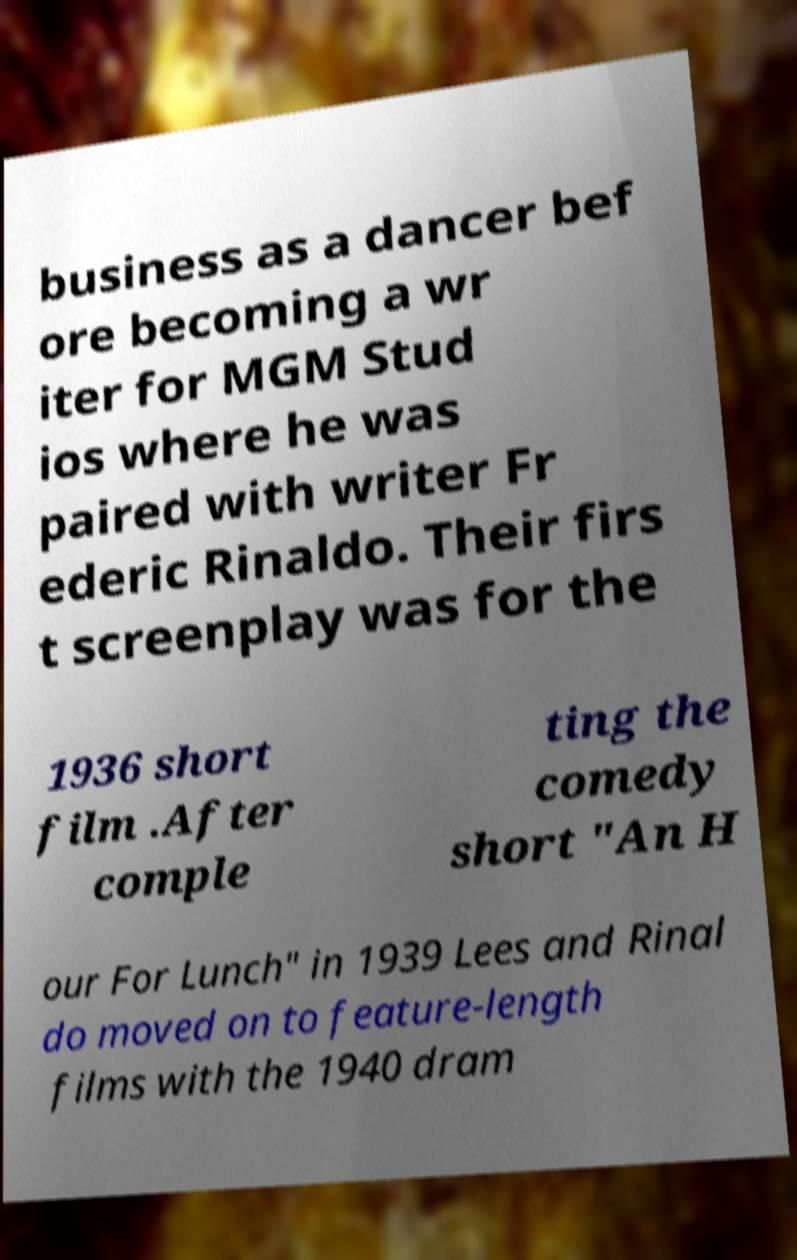Could you extract and type out the text from this image? business as a dancer bef ore becoming a wr iter for MGM Stud ios where he was paired with writer Fr ederic Rinaldo. Their firs t screenplay was for the 1936 short film .After comple ting the comedy short "An H our For Lunch" in 1939 Lees and Rinal do moved on to feature-length films with the 1940 dram 